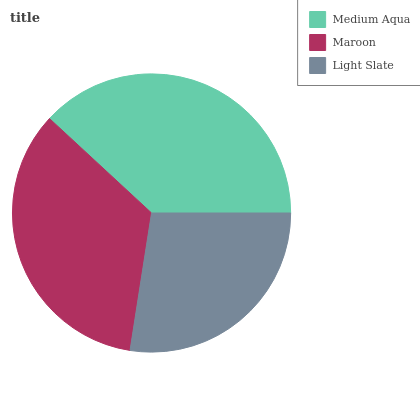Is Light Slate the minimum?
Answer yes or no. Yes. Is Medium Aqua the maximum?
Answer yes or no. Yes. Is Maroon the minimum?
Answer yes or no. No. Is Maroon the maximum?
Answer yes or no. No. Is Medium Aqua greater than Maroon?
Answer yes or no. Yes. Is Maroon less than Medium Aqua?
Answer yes or no. Yes. Is Maroon greater than Medium Aqua?
Answer yes or no. No. Is Medium Aqua less than Maroon?
Answer yes or no. No. Is Maroon the high median?
Answer yes or no. Yes. Is Maroon the low median?
Answer yes or no. Yes. Is Light Slate the high median?
Answer yes or no. No. Is Light Slate the low median?
Answer yes or no. No. 